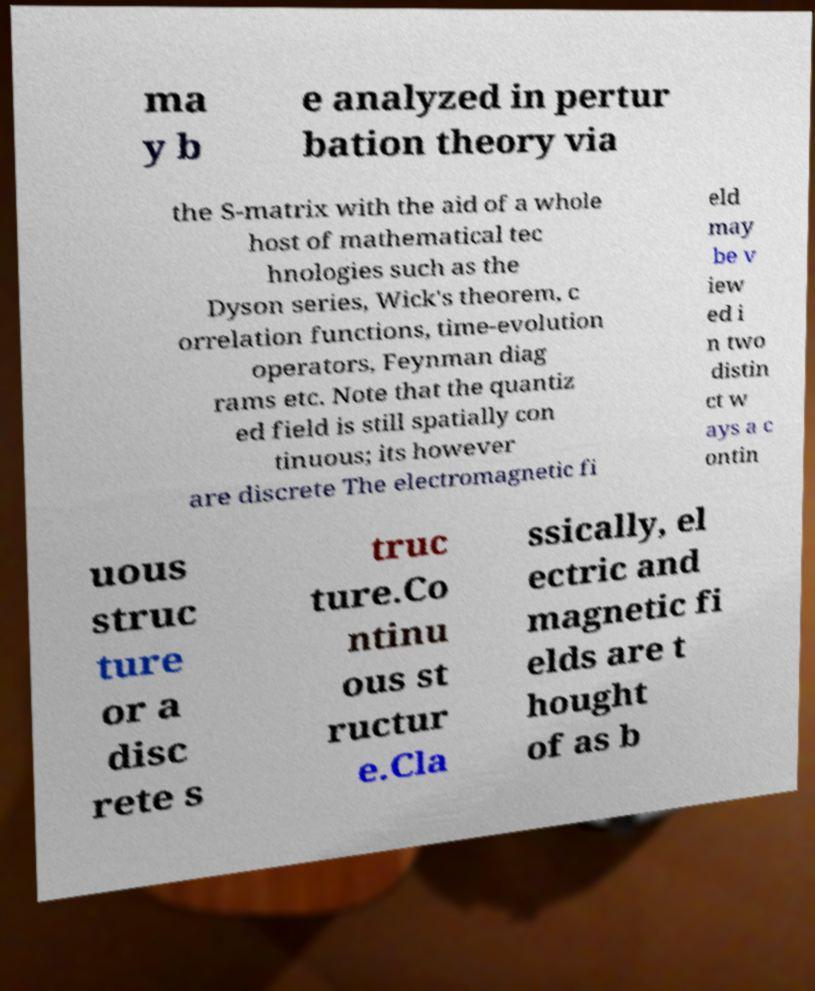Please read and relay the text visible in this image. What does it say? ma y b e analyzed in pertur bation theory via the S-matrix with the aid of a whole host of mathematical tec hnologies such as the Dyson series, Wick's theorem, c orrelation functions, time-evolution operators, Feynman diag rams etc. Note that the quantiz ed field is still spatially con tinuous; its however are discrete The electromagnetic fi eld may be v iew ed i n two distin ct w ays a c ontin uous struc ture or a disc rete s truc ture.Co ntinu ous st ructur e.Cla ssically, el ectric and magnetic fi elds are t hought of as b 